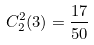<formula> <loc_0><loc_0><loc_500><loc_500>C _ { 2 } ^ { 2 } ( 3 ) = \frac { 1 7 } { 5 0 }</formula> 